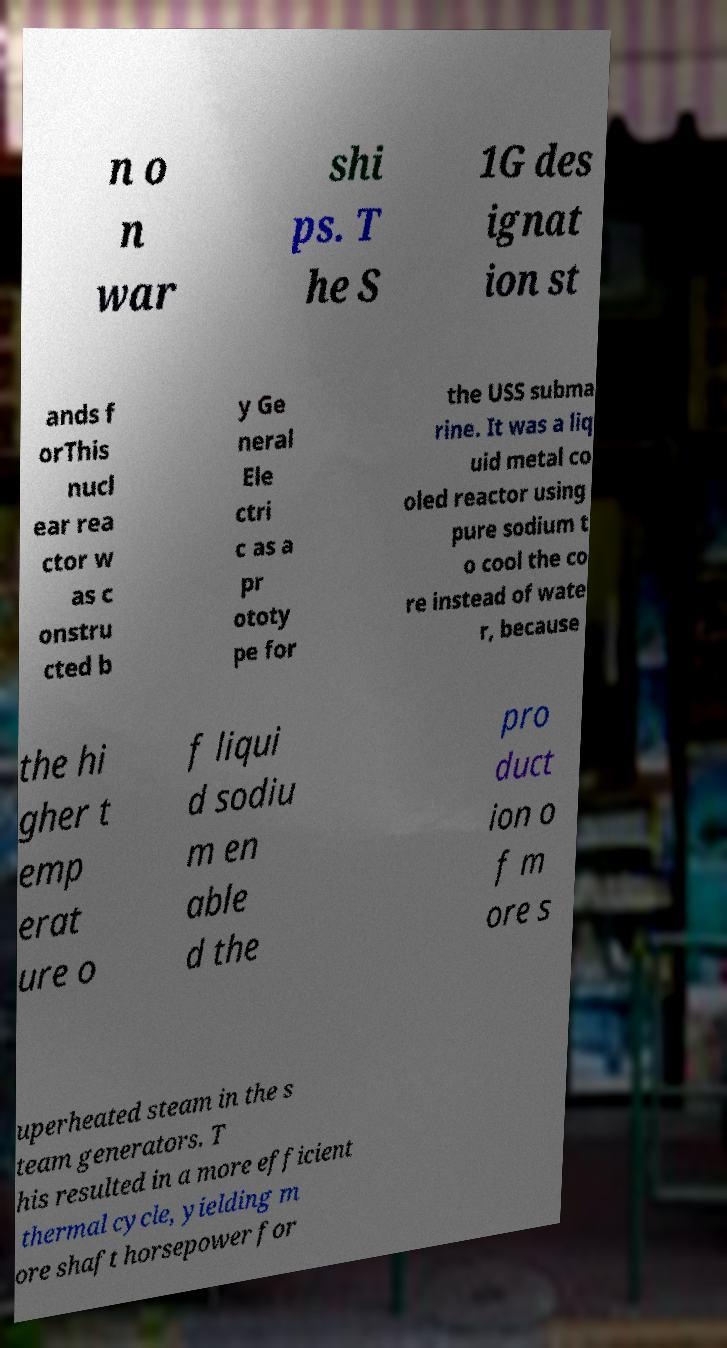Please read and relay the text visible in this image. What does it say? n o n war shi ps. T he S 1G des ignat ion st ands f orThis nucl ear rea ctor w as c onstru cted b y Ge neral Ele ctri c as a pr ototy pe for the USS subma rine. It was a liq uid metal co oled reactor using pure sodium t o cool the co re instead of wate r, because the hi gher t emp erat ure o f liqui d sodiu m en able d the pro duct ion o f m ore s uperheated steam in the s team generators. T his resulted in a more efficient thermal cycle, yielding m ore shaft horsepower for 